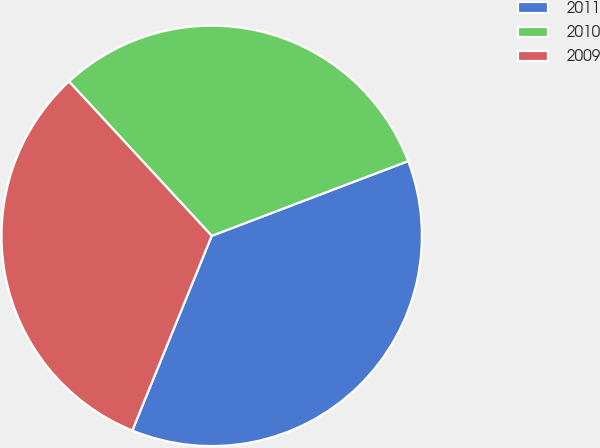<chart> <loc_0><loc_0><loc_500><loc_500><pie_chart><fcel>2011<fcel>2010<fcel>2009<nl><fcel>36.95%<fcel>31.09%<fcel>31.96%<nl></chart> 